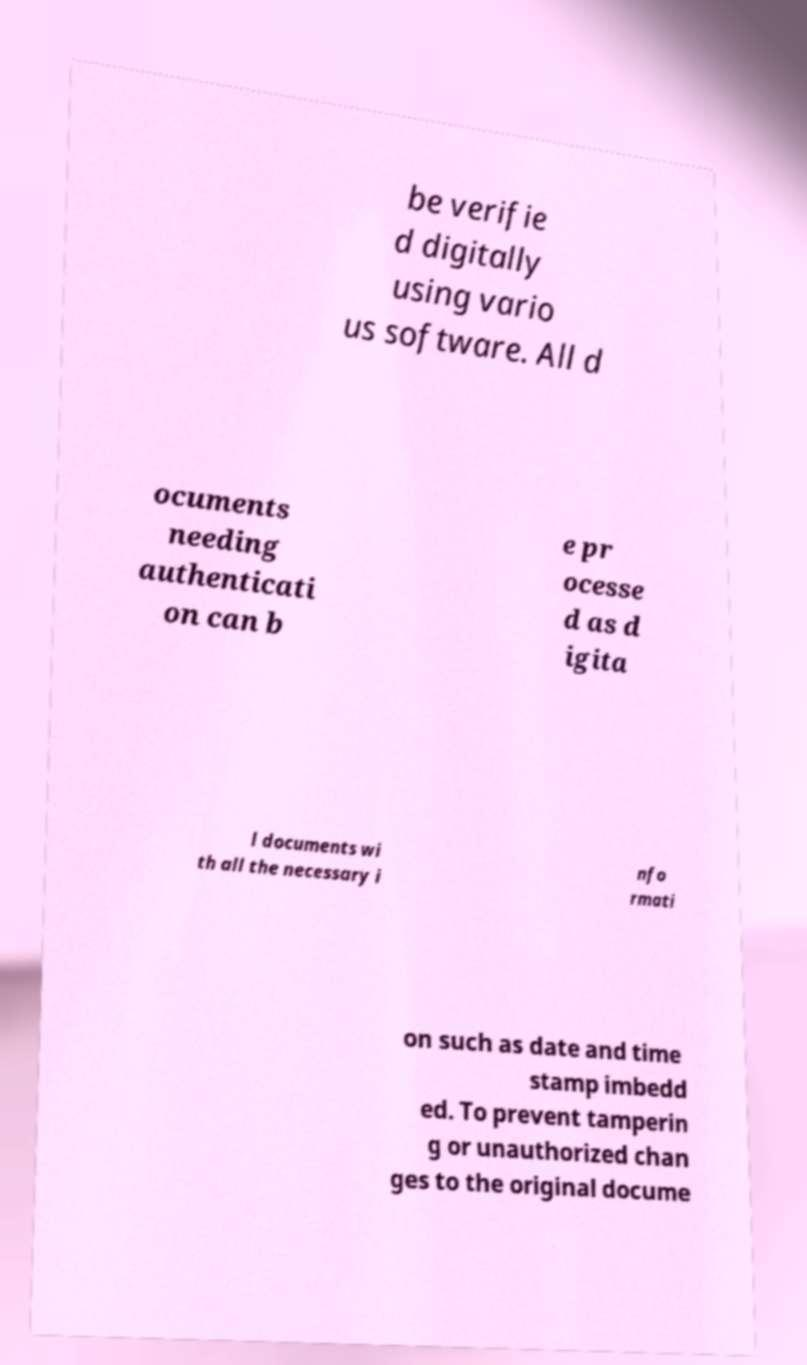Please identify and transcribe the text found in this image. be verifie d digitally using vario us software. All d ocuments needing authenticati on can b e pr ocesse d as d igita l documents wi th all the necessary i nfo rmati on such as date and time stamp imbedd ed. To prevent tamperin g or unauthorized chan ges to the original docume 